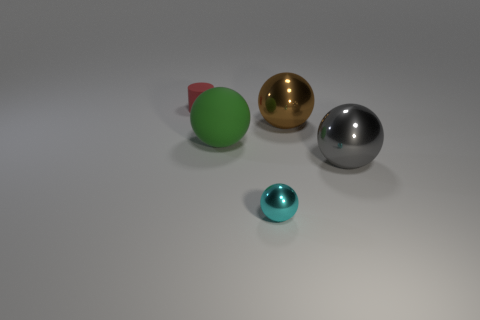There is a tiny red object that is on the left side of the sphere that is to the right of the brown thing; what shape is it? The tiny red object in question appears to be more of a conical shape, with its base on the left side of the gold sphere. 